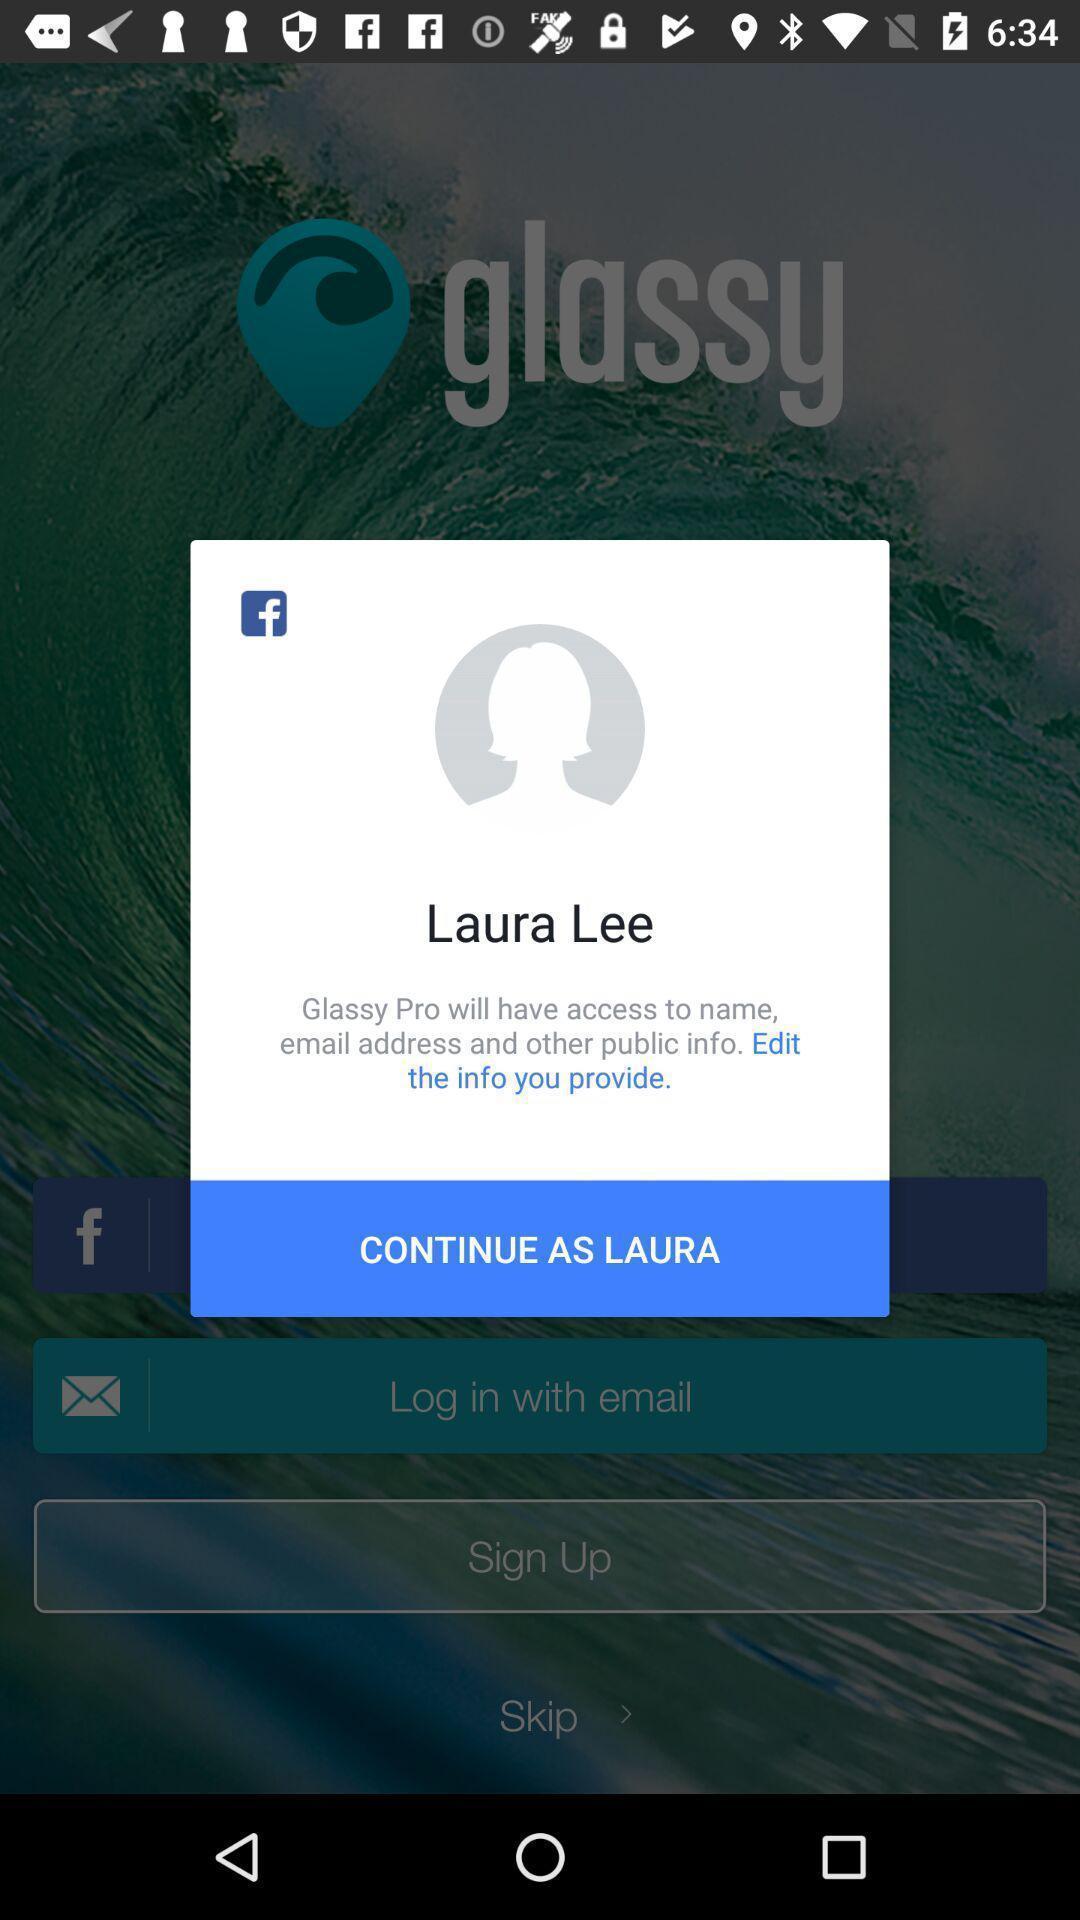Provide a detailed account of this screenshot. Pop-up displaying to continue in app. 